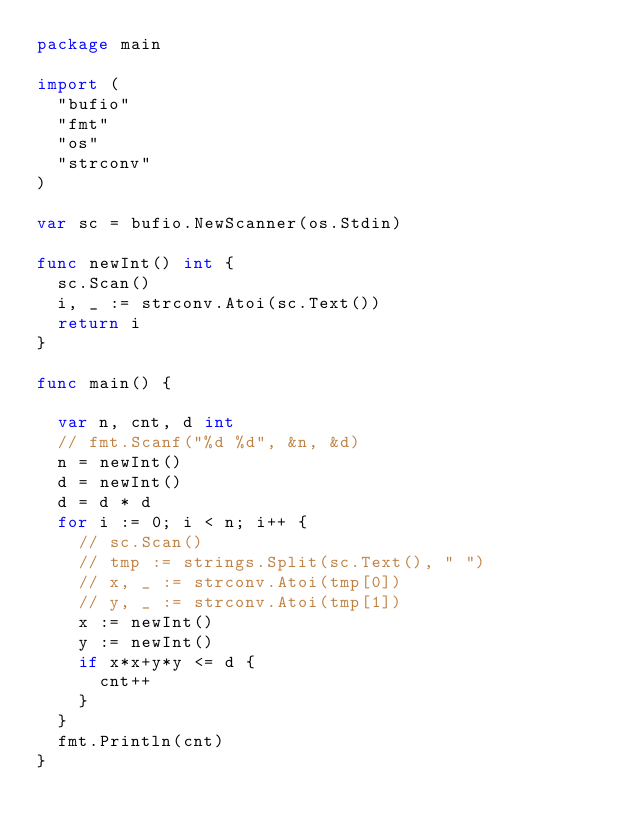<code> <loc_0><loc_0><loc_500><loc_500><_Go_>package main

import (
	"bufio"
	"fmt"
	"os"
	"strconv"
)

var sc = bufio.NewScanner(os.Stdin)

func newInt() int {
	sc.Scan()
	i, _ := strconv.Atoi(sc.Text())
	return i
}

func main() {

	var n, cnt, d int
	// fmt.Scanf("%d %d", &n, &d)
	n = newInt()
	d = newInt()
	d = d * d
	for i := 0; i < n; i++ {
		// sc.Scan()
		// tmp := strings.Split(sc.Text(), " ")
		// x, _ := strconv.Atoi(tmp[0])
		// y, _ := strconv.Atoi(tmp[1])
		x := newInt()
		y := newInt()
		if x*x+y*y <= d {
			cnt++
		}
	}
	fmt.Println(cnt)
}
</code> 